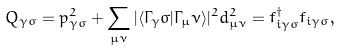<formula> <loc_0><loc_0><loc_500><loc_500>Q _ { \gamma \sigma } = p _ { \gamma \sigma } ^ { 2 } + \sum _ { \mu \nu } | \langle \Gamma _ { \gamma } \sigma | \Gamma _ { \mu } \nu \rangle | ^ { 2 } d _ { \mu \nu } ^ { 2 } = f ^ { \dagger } _ { i \gamma \sigma } f _ { i \gamma \sigma } ,</formula> 